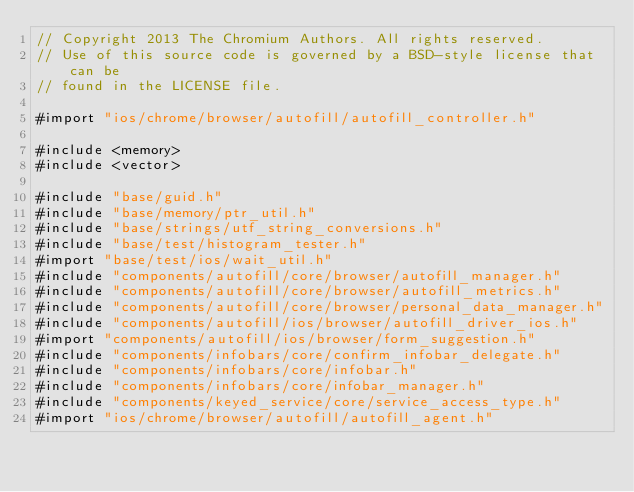<code> <loc_0><loc_0><loc_500><loc_500><_ObjectiveC_>// Copyright 2013 The Chromium Authors. All rights reserved.
// Use of this source code is governed by a BSD-style license that can be
// found in the LICENSE file.

#import "ios/chrome/browser/autofill/autofill_controller.h"

#include <memory>
#include <vector>

#include "base/guid.h"
#include "base/memory/ptr_util.h"
#include "base/strings/utf_string_conversions.h"
#include "base/test/histogram_tester.h"
#import "base/test/ios/wait_util.h"
#include "components/autofill/core/browser/autofill_manager.h"
#include "components/autofill/core/browser/autofill_metrics.h"
#include "components/autofill/core/browser/personal_data_manager.h"
#include "components/autofill/ios/browser/autofill_driver_ios.h"
#import "components/autofill/ios/browser/form_suggestion.h"
#include "components/infobars/core/confirm_infobar_delegate.h"
#include "components/infobars/core/infobar.h"
#include "components/infobars/core/infobar_manager.h"
#include "components/keyed_service/core/service_access_type.h"
#import "ios/chrome/browser/autofill/autofill_agent.h"</code> 